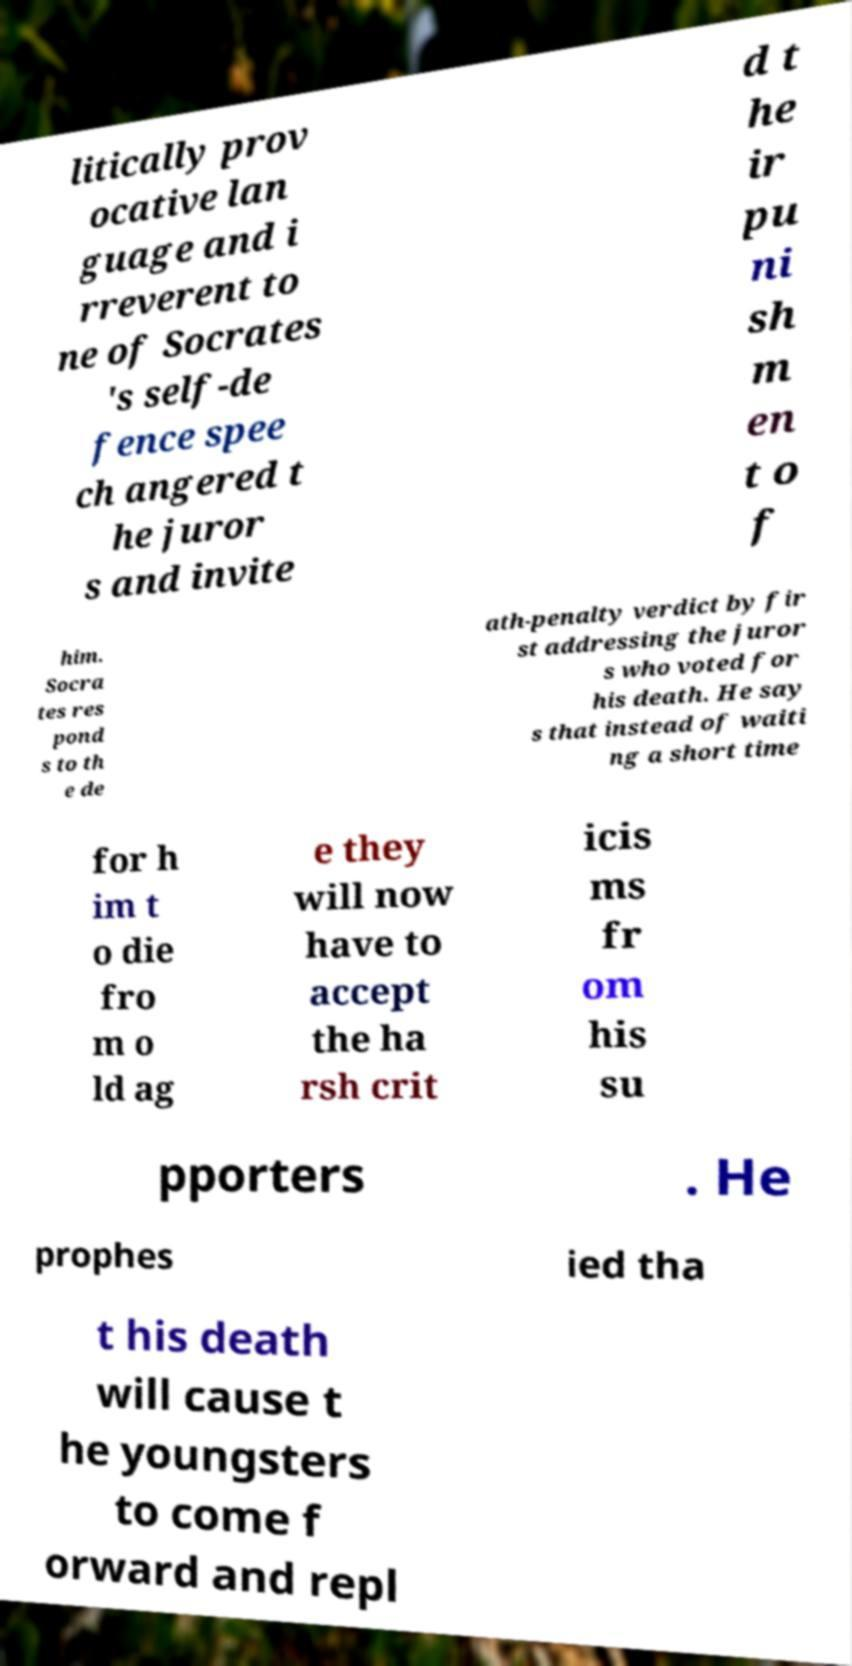What messages or text are displayed in this image? I need them in a readable, typed format. litically prov ocative lan guage and i rreverent to ne of Socrates 's self-de fence spee ch angered t he juror s and invite d t he ir pu ni sh m en t o f him. Socra tes res pond s to th e de ath-penalty verdict by fir st addressing the juror s who voted for his death. He say s that instead of waiti ng a short time for h im t o die fro m o ld ag e they will now have to accept the ha rsh crit icis ms fr om his su pporters . He prophes ied tha t his death will cause t he youngsters to come f orward and repl 